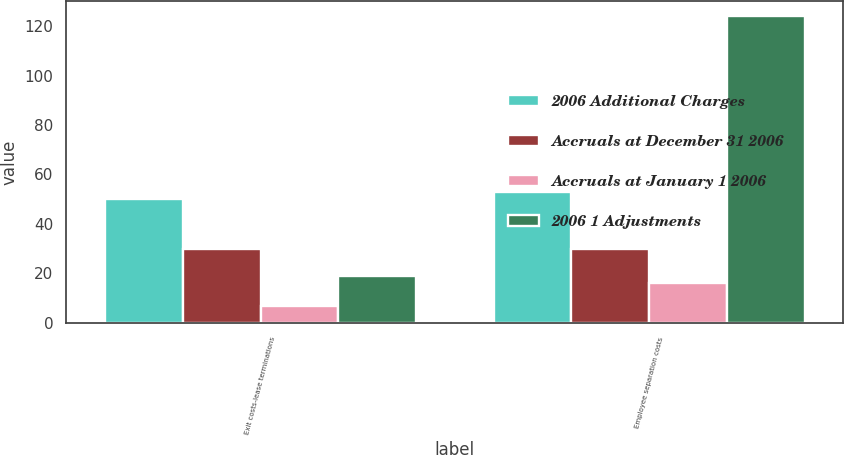Convert chart to OTSL. <chart><loc_0><loc_0><loc_500><loc_500><stacked_bar_chart><ecel><fcel>Exit costs-lease terminations<fcel>Employee separation costs<nl><fcel>2006 Additional Charges<fcel>50<fcel>53<nl><fcel>Accruals at December 31 2006<fcel>30<fcel>30<nl><fcel>Accruals at January 1 2006<fcel>7<fcel>16<nl><fcel>2006 1 Adjustments<fcel>19<fcel>124<nl></chart> 